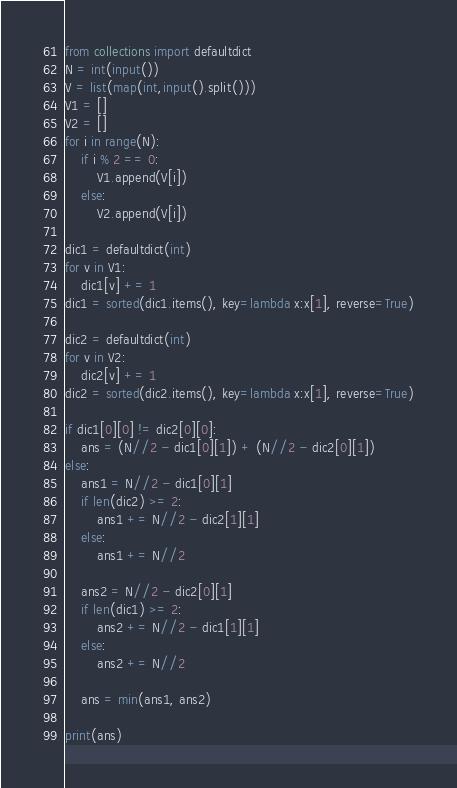Convert code to text. <code><loc_0><loc_0><loc_500><loc_500><_Python_>from collections import defaultdict
N = int(input())
V = list(map(int,input().split()))
V1 = []
V2 = []
for i in range(N):
    if i % 2 == 0:
        V1.append(V[i])
    else:
        V2.append(V[i])

dic1 = defaultdict(int)
for v in V1:
    dic1[v] += 1
dic1 = sorted(dic1.items(), key=lambda x:x[1], reverse=True)

dic2 = defaultdict(int)
for v in V2:
    dic2[v] += 1
dic2 = sorted(dic2.items(), key=lambda x:x[1], reverse=True)

if dic1[0][0] != dic2[0][0]:
    ans = (N//2 - dic1[0][1]) + (N//2 - dic2[0][1])
else:
    ans1 = N//2 - dic1[0][1]
    if len(dic2) >= 2:
        ans1 += N//2 - dic2[1][1]
    else:
        ans1 += N//2

    ans2 = N//2 - dic2[0][1]
    if len(dic1) >= 2:
        ans2 += N//2 - dic1[1][1]
    else:
        ans2 += N//2

    ans = min(ans1, ans2)

print(ans)</code> 